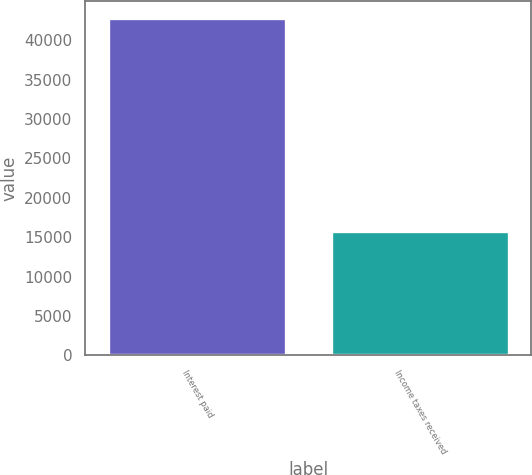<chart> <loc_0><loc_0><loc_500><loc_500><bar_chart><fcel>Interest paid<fcel>Income taxes received<nl><fcel>42813<fcel>15725<nl></chart> 